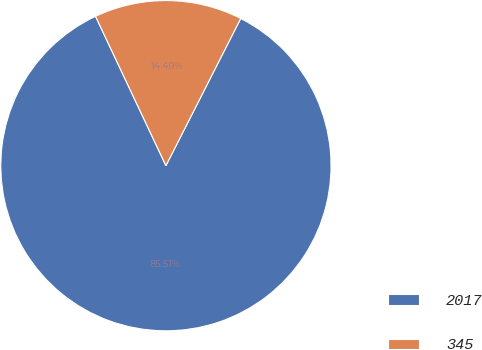Convert chart. <chart><loc_0><loc_0><loc_500><loc_500><pie_chart><fcel>2017<fcel>345<nl><fcel>85.51%<fcel>14.49%<nl></chart> 